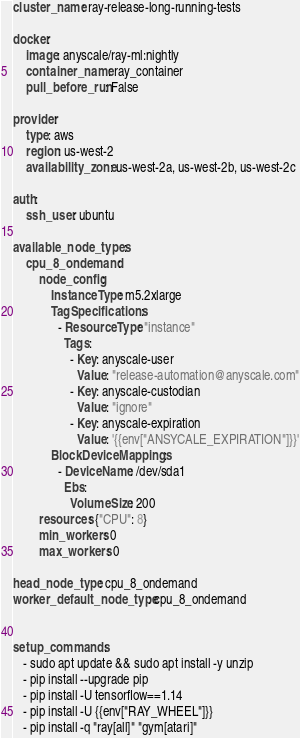<code> <loc_0><loc_0><loc_500><loc_500><_YAML_>cluster_name: ray-release-long-running-tests

docker:
    image: anyscale/ray-ml:nightly
    container_name: ray_container
    pull_before_run: False

provider:
    type: aws
    region: us-west-2
    availability_zone: us-west-2a, us-west-2b, us-west-2c

auth:
    ssh_user: ubuntu

available_node_types:
    cpu_8_ondemand:
        node_config:
            InstanceType: m5.2xlarge
            TagSpecifications:
              - ResourceType: "instance"
                Tags:
                  - Key: anyscale-user
                    Value: "release-automation@anyscale.com"
                  - Key: anyscale-custodian
                    Value: "ignore"
                  - Key: anyscale-expiration
                    Value: '{{env["ANSYCALE_EXPIRATION"]}}'
            BlockDeviceMappings:
              - DeviceName: /dev/sda1
                Ebs:
                  VolumeSize: 200
        resources: {"CPU": 8}
        min_workers: 0
        max_workers: 0

head_node_type: cpu_8_ondemand
worker_default_node_type: cpu_8_ondemand


setup_commands:
   - sudo apt update && sudo apt install -y unzip
   - pip install --upgrade pip
   - pip install -U tensorflow==1.14
   - pip install -U {{env["RAY_WHEEL"]}}
   - pip install -q "ray[all]" "gym[atari]"
</code> 